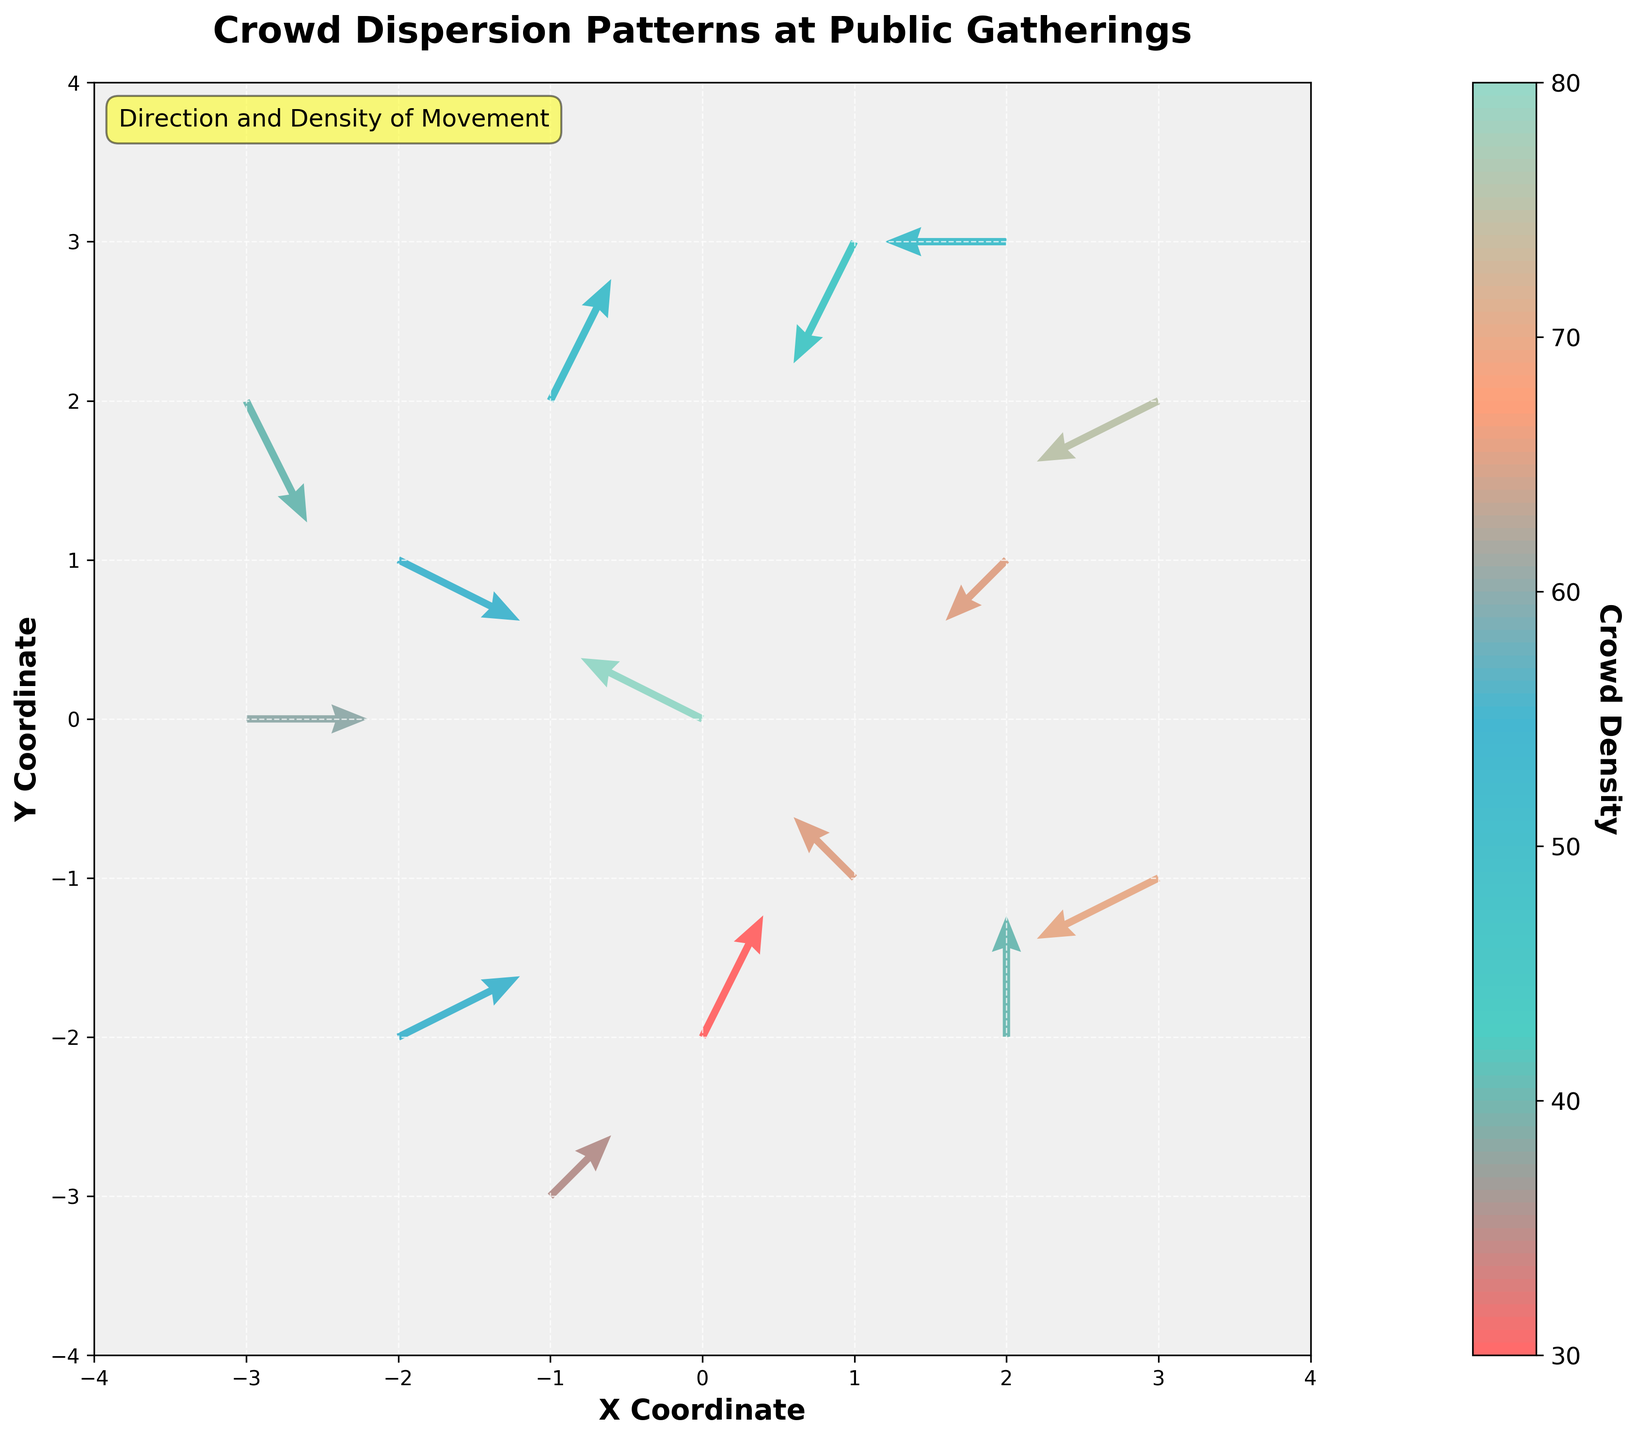What is the title of the plot? The title is usually placed at the top of the figure and summarizes the main focus of the plot. In this case, "Crowd Dispersion Patterns at Public Gatherings" indicates that the plot displays how crowds are moving and their density at public gatherings.
Answer: Crowd Dispersion Patterns at Public Gatherings What do the colors in the quiver plot represent? The color bar is usually an indication of what the colors represent. Here, the color bar's label "Crowd Density" shows that different colors represent different levels of crowd density.
Answer: Crowd density Which axis represents the Y Coordinate? The Y axis is usually the vertical axis on the plot. This can be confirmed by the axis label "Y Coordinate"
Answer: The vertical axis What is the direction of movement at coordinates (2, 1)? Identify the arrow starting at (2, 1) and look at its direction. The arrow points in the negative x-direction and negative y-direction.
Answer: Negative x-direction and negative y-direction What is the crowd density at coordinates (-3, 2)? Find the arrow starting at (-3, 2) and note the corresponding color. Comparing this color to the color bar, it is approximately equal to the density closest to 40.
Answer: 40 How many data points indicate crowd movement directions? Count the number of arrows in the plot. The data table lists the arrows indicating crowd movement, with one arrow per row.
Answer: 15 Which coordinate has the highest crowd density? Examine the arrow colors and compare them using the color bar. The densest color corresponds to the highest density value. Here, coordinates (0, 0) have the highest density of 80.
Answer: (0, 0) Where are there zero movements in any direction? Check for arrows with either zero x or y components. The arrow at coordinates (2, -2) only has movement in the y direction and no movement in the x direction, indicating no movement in at least one direction.
Answer: (2, -2) Compare the directions of arrows at coordinates (1, -1) and (-1, 3). Look at the directions and components of the arrows starting at these coordinates. Arrows at (1, -1) point in the negative x and positive y directions, whereas arrows at (-1, 3) point in the positive x and negative y directions.
Answer: Negative x and positive y vs. positive x and negative y What does a wider grid and smaller arrowheads indicate in this plot? Examine the scale and width parameters of the arrows. A wider grid with smaller arrowheads generally indicates a higher density and closer focus on individual movements.
Answer: Higher density and focused movement 